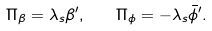<formula> <loc_0><loc_0><loc_500><loc_500>\Pi _ { \beta } = \lambda _ { s } \beta ^ { \prime } , \quad \Pi _ { \phi } = - \lambda _ { s } \bar { \phi } ^ { \prime } .</formula> 